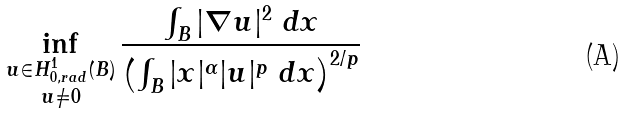<formula> <loc_0><loc_0><loc_500><loc_500>\inf _ { \substack { u \in H _ { 0 , r a d } ^ { 1 } ( B ) \\ u \neq 0 } } \frac { \int _ { B } | \nabla u | ^ { 2 } \ d x } { \left ( \int _ { B } | x | ^ { \alpha } | u | ^ { p } \ d x \right ) ^ { 2 / p } }</formula> 